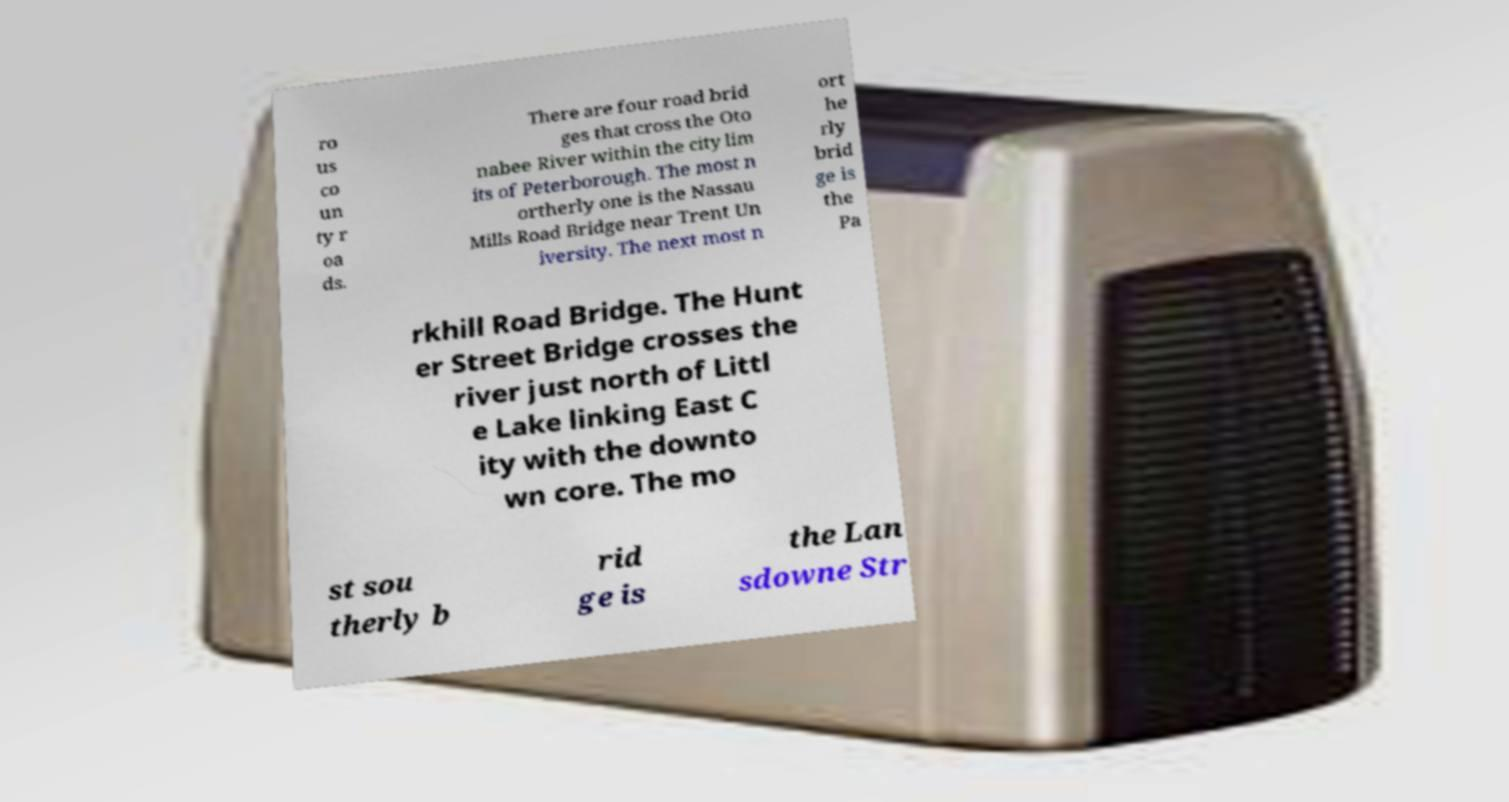Please identify and transcribe the text found in this image. ro us co un ty r oa ds. There are four road brid ges that cross the Oto nabee River within the city lim its of Peterborough. The most n ortherly one is the Nassau Mills Road Bridge near Trent Un iversity. The next most n ort he rly brid ge is the Pa rkhill Road Bridge. The Hunt er Street Bridge crosses the river just north of Littl e Lake linking East C ity with the downto wn core. The mo st sou therly b rid ge is the Lan sdowne Str 